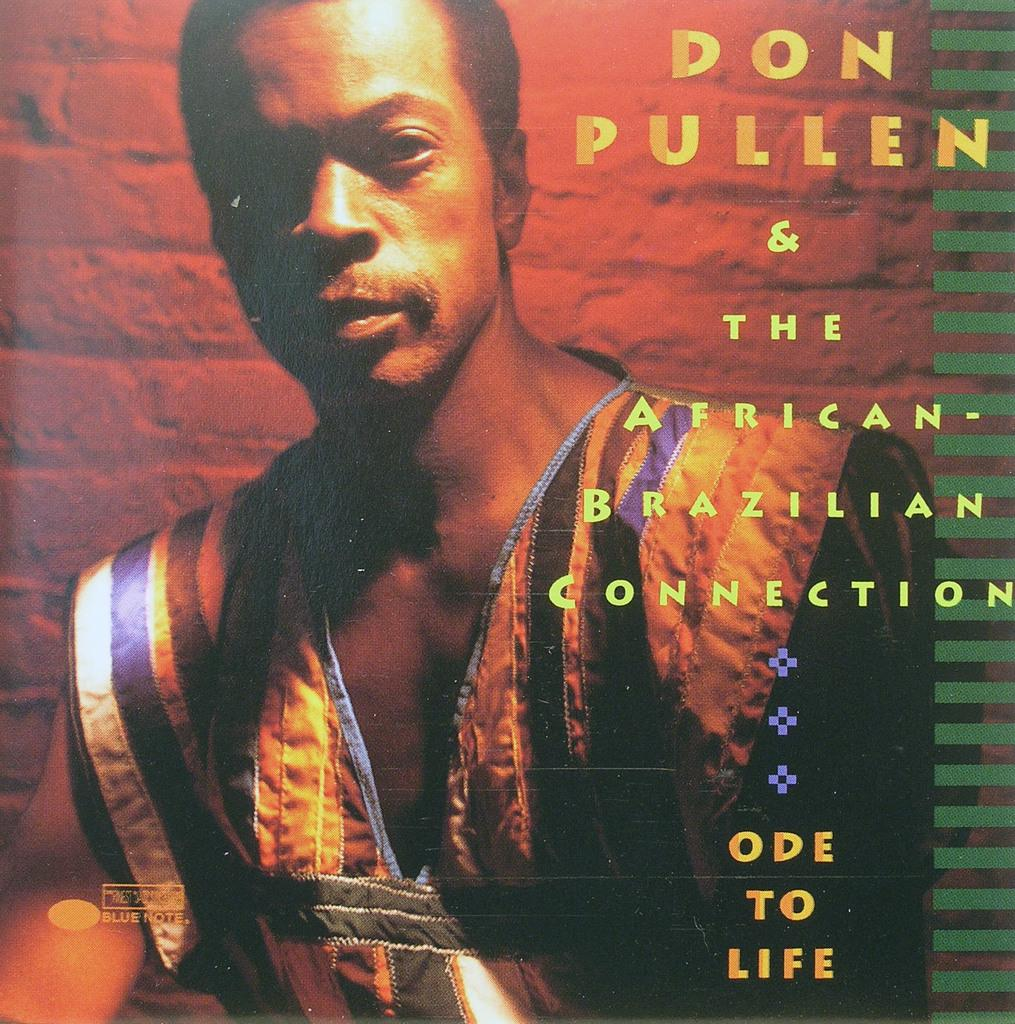<image>
Create a compact narrative representing the image presented. A CD by Don Pullen and the African Connection. 